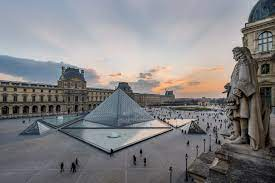Can you reflect on the contrast between the pyramid and the surrounding architecture? Certainly. The contrast between the modernity of the glass pyramid and the traditional European architecture of the surrounding Louvre Palace is striking. The pyramid's sharp geometric lines and transparent structure are a stark departure from the ornate facades, sculptures, and intricate detailing of the historic palace. This juxtaposition creates a visual dialogue between the past and the present, symbolizing the museum's dedication to both the preservation of history and the embrace of contemporary innovation. 